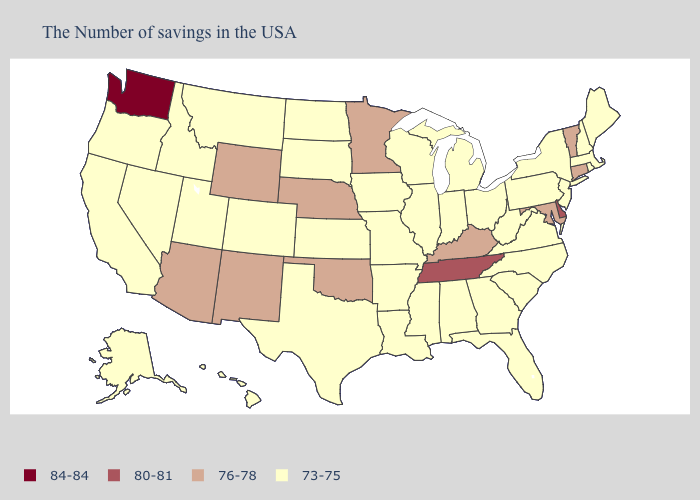What is the highest value in states that border Michigan?
Keep it brief. 73-75. Name the states that have a value in the range 73-75?
Quick response, please. Maine, Massachusetts, Rhode Island, New Hampshire, New York, New Jersey, Pennsylvania, Virginia, North Carolina, South Carolina, West Virginia, Ohio, Florida, Georgia, Michigan, Indiana, Alabama, Wisconsin, Illinois, Mississippi, Louisiana, Missouri, Arkansas, Iowa, Kansas, Texas, South Dakota, North Dakota, Colorado, Utah, Montana, Idaho, Nevada, California, Oregon, Alaska, Hawaii. Does Nebraska have the highest value in the MidWest?
Keep it brief. Yes. Name the states that have a value in the range 84-84?
Quick response, please. Washington. Does Arkansas have a lower value than Kentucky?
Keep it brief. Yes. What is the lowest value in the South?
Keep it brief. 73-75. Does Illinois have a higher value than Minnesota?
Short answer required. No. Does New Hampshire have the lowest value in the Northeast?
Be succinct. Yes. Is the legend a continuous bar?
Write a very short answer. No. What is the highest value in the USA?
Concise answer only. 84-84. Among the states that border South Dakota , which have the highest value?
Keep it brief. Minnesota, Nebraska, Wyoming. Among the states that border Vermont , which have the highest value?
Short answer required. Massachusetts, New Hampshire, New York. What is the lowest value in the USA?
Give a very brief answer. 73-75. What is the value of Hawaii?
Write a very short answer. 73-75. What is the value of Alabama?
Concise answer only. 73-75. 